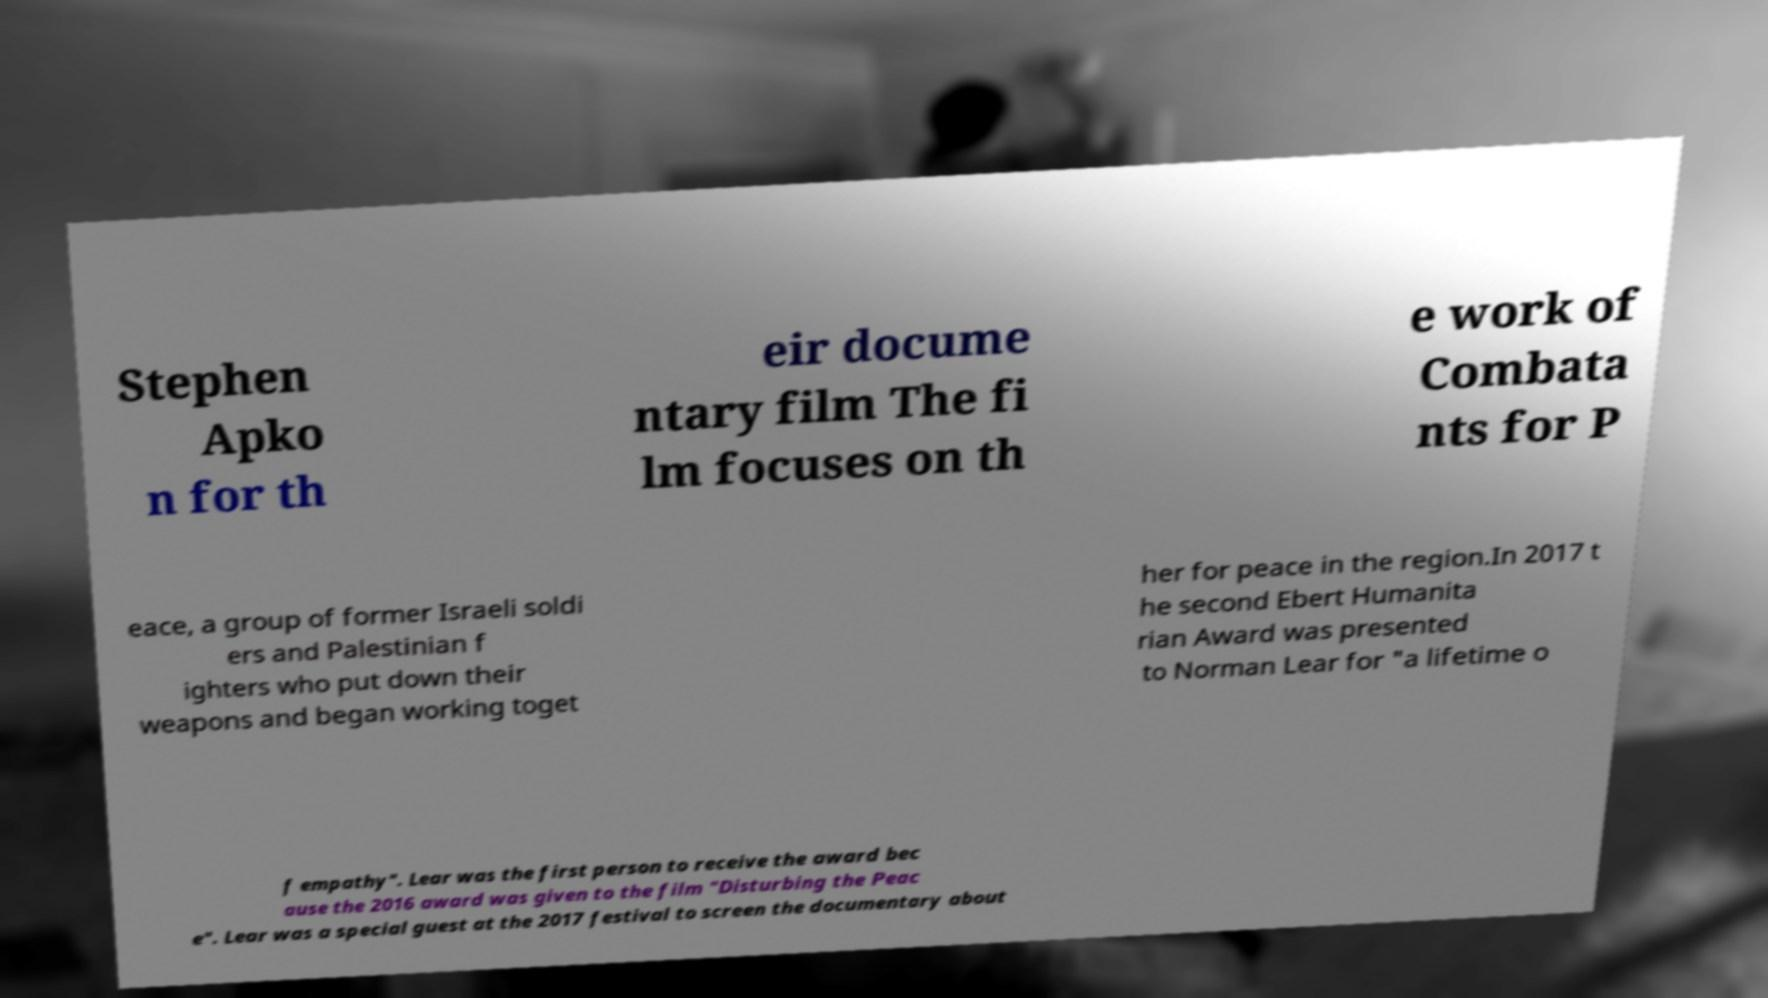For documentation purposes, I need the text within this image transcribed. Could you provide that? Stephen Apko n for th eir docume ntary film The fi lm focuses on th e work of Combata nts for P eace, a group of former Israeli soldi ers and Palestinian f ighters who put down their weapons and began working toget her for peace in the region.In 2017 t he second Ebert Humanita rian Award was presented to Norman Lear for "a lifetime o f empathy". Lear was the first person to receive the award bec ause the 2016 award was given to the film "Disturbing the Peac e". Lear was a special guest at the 2017 festival to screen the documentary about 